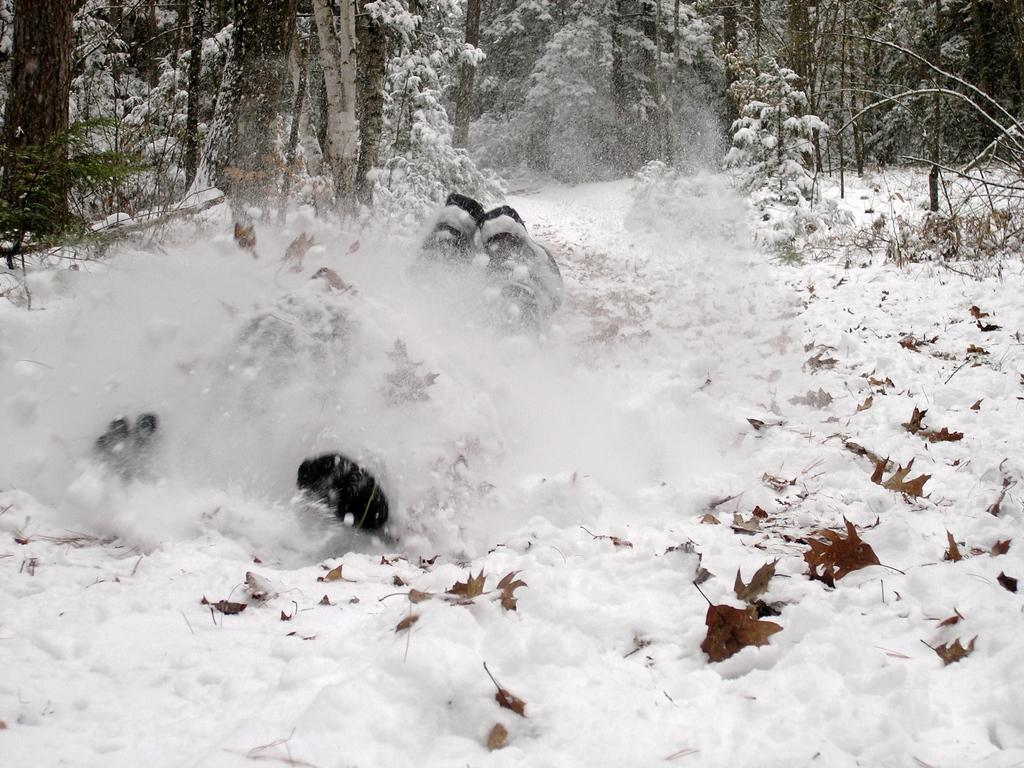What type of weather condition is depicted in the image? There is snow on the surface in the image, indicating a snowy or wintry condition. What can be seen in the background of the image? There are trees in the background of the image. What color is the nose of the person in the image? There is no person present in the image, so it is not possible to determine the color of their nose. 